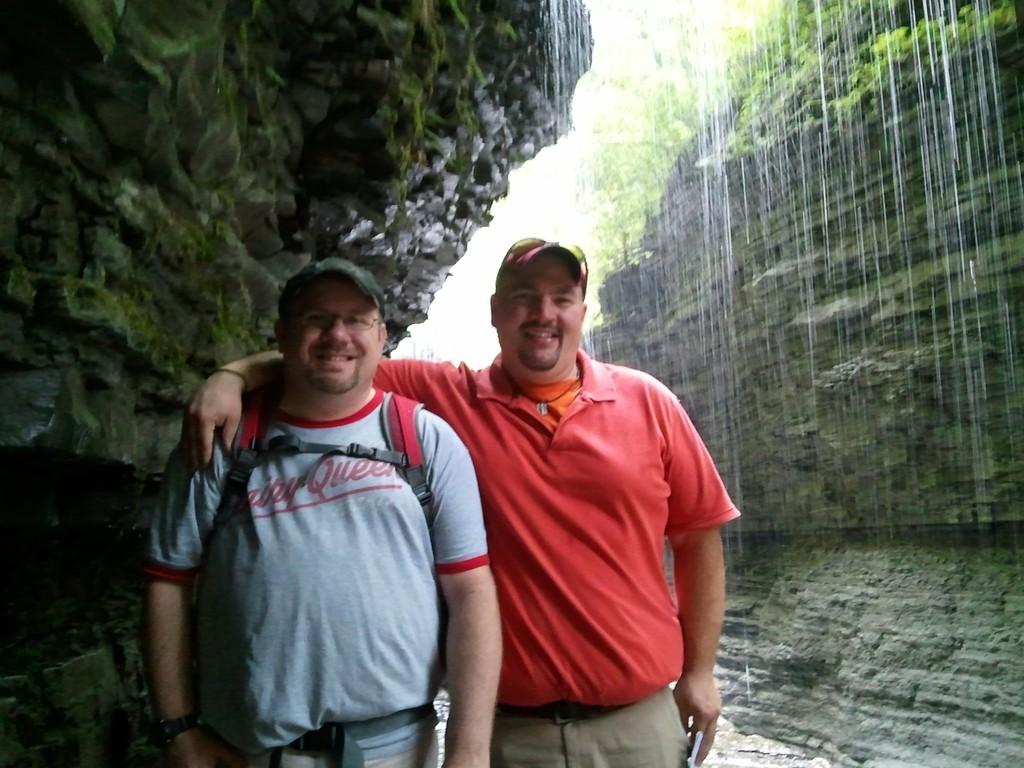What popular icecream shop is depicting on the mans shirt?
Keep it short and to the point. Dairy queen. 